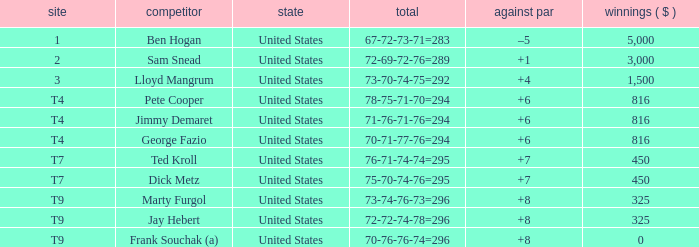Which country is Pete Cooper, who made $816, from? United States. Parse the table in full. {'header': ['site', 'competitor', 'state', 'total', 'against par', 'winnings ( $ )'], 'rows': [['1', 'Ben Hogan', 'United States', '67-72-73-71=283', '–5', '5,000'], ['2', 'Sam Snead', 'United States', '72-69-72-76=289', '+1', '3,000'], ['3', 'Lloyd Mangrum', 'United States', '73-70-74-75=292', '+4', '1,500'], ['T4', 'Pete Cooper', 'United States', '78-75-71-70=294', '+6', '816'], ['T4', 'Jimmy Demaret', 'United States', '71-76-71-76=294', '+6', '816'], ['T4', 'George Fazio', 'United States', '70-71-77-76=294', '+6', '816'], ['T7', 'Ted Kroll', 'United States', '76-71-74-74=295', '+7', '450'], ['T7', 'Dick Metz', 'United States', '75-70-74-76=295', '+7', '450'], ['T9', 'Marty Furgol', 'United States', '73-74-76-73=296', '+8', '325'], ['T9', 'Jay Hebert', 'United States', '72-72-74-78=296', '+8', '325'], ['T9', 'Frank Souchak (a)', 'United States', '70-76-76-74=296', '+8', '0']]} 